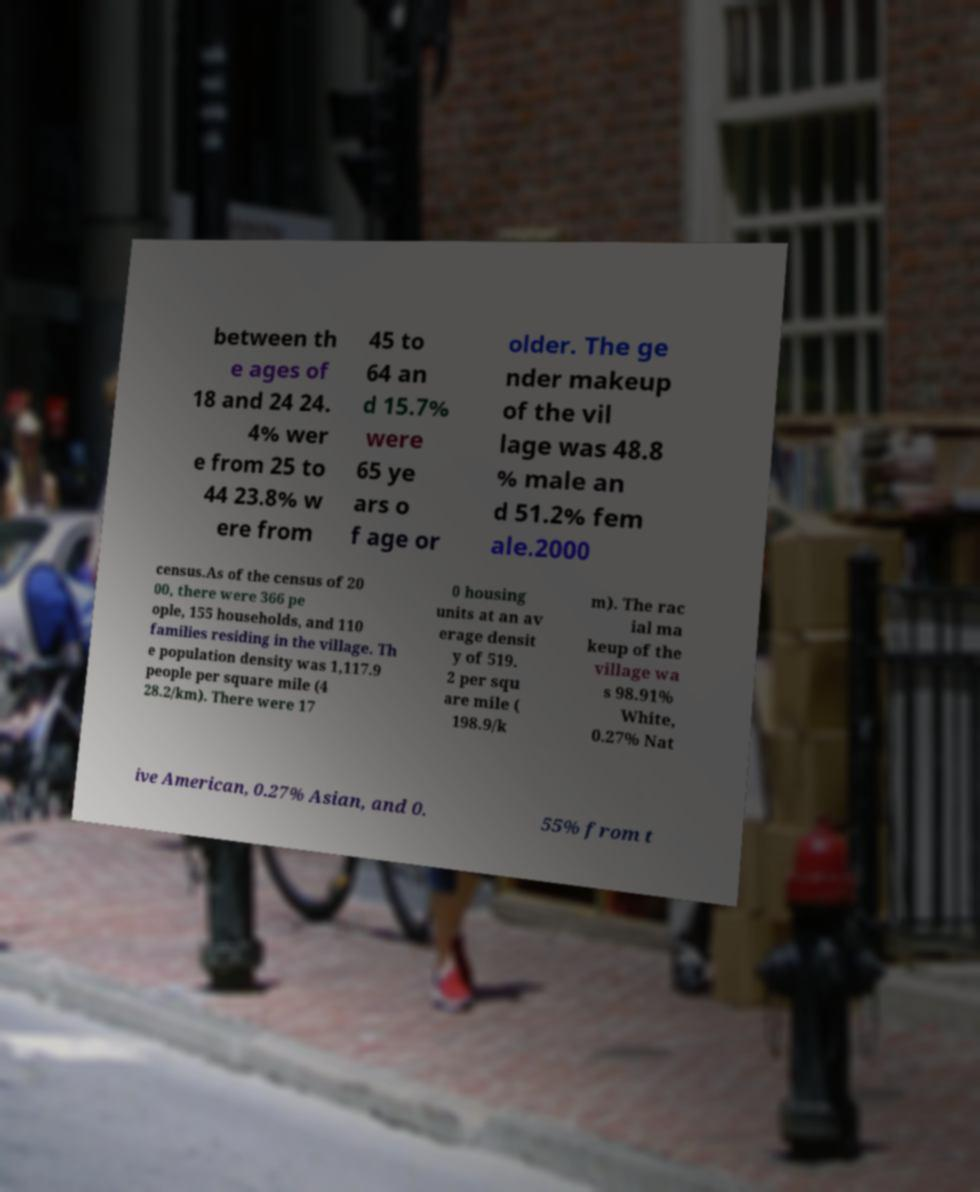For documentation purposes, I need the text within this image transcribed. Could you provide that? between th e ages of 18 and 24 24. 4% wer e from 25 to 44 23.8% w ere from 45 to 64 an d 15.7% were 65 ye ars o f age or older. The ge nder makeup of the vil lage was 48.8 % male an d 51.2% fem ale.2000 census.As of the census of 20 00, there were 366 pe ople, 155 households, and 110 families residing in the village. Th e population density was 1,117.9 people per square mile (4 28.2/km). There were 17 0 housing units at an av erage densit y of 519. 2 per squ are mile ( 198.9/k m). The rac ial ma keup of the village wa s 98.91% White, 0.27% Nat ive American, 0.27% Asian, and 0. 55% from t 